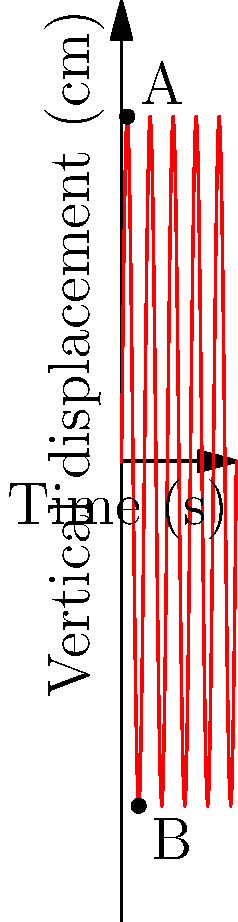In the Schuhplattler, a traditional Bavarian folk dance, the vertical motion of a dancer's foot during a typical slap movement is represented by the sinusoidal curve above. If the dancer's foot moves from point A to point B in 0.5 seconds, what is the average velocity of the foot during this motion? To calculate the average velocity, we need to determine the displacement and time taken:

1. Displacement:
   - At point A: $y_A = 15$ cm
   - At point B: $y_B = -15$ cm
   - Total vertical displacement = $y_B - y_A = -15 - 15 = -30$ cm

2. Time taken:
   - From the question, we know it takes 0.5 seconds to move from A to B.

3. Average velocity formula:
   $v_{avg} = \frac{\text{displacement}}{\text{time}}$

4. Substituting the values:
   $v_{avg} = \frac{-30 \text{ cm}}{0.5 \text{ s}} = -60 \text{ cm/s}$

5. Convert to m/s:
   $v_{avg} = -60 \text{ cm/s} \times \frac{1 \text{ m}}{100 \text{ cm}} = -0.6 \text{ m/s}$

The negative sign indicates downward motion.
Answer: $-0.6 \text{ m/s}$ 